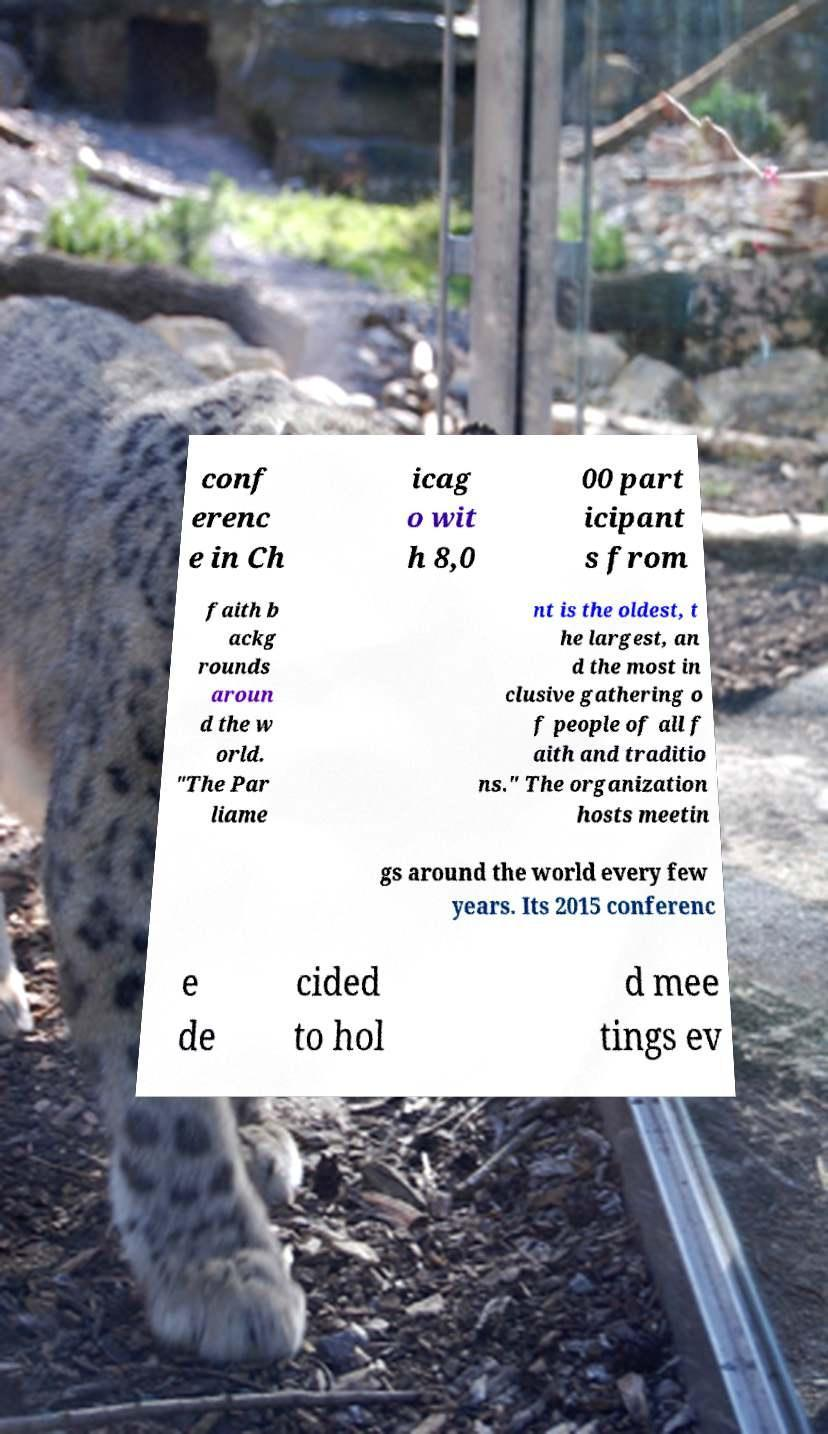Please identify and transcribe the text found in this image. conf erenc e in Ch icag o wit h 8,0 00 part icipant s from faith b ackg rounds aroun d the w orld. "The Par liame nt is the oldest, t he largest, an d the most in clusive gathering o f people of all f aith and traditio ns." The organization hosts meetin gs around the world every few years. Its 2015 conferenc e de cided to hol d mee tings ev 